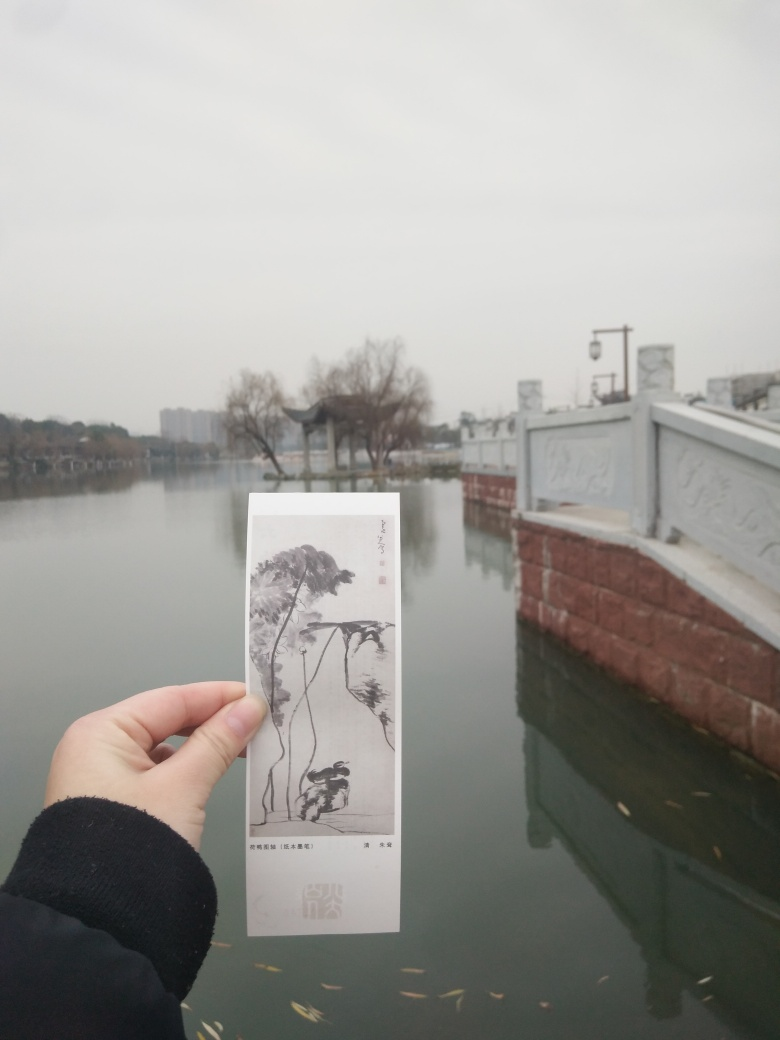Is the picture overall blurry? The assessment of the image's clarity is partly subjective, but it can be observed that the focus is not sharp throughout the picture. The foreground, featuring a hand holding a bookmark with artwork, is relatively clear, while the background, including the waterscape and structures, exhibits some degree of blurriness, likely due to the focal depth of the camera when the photo was taken. 